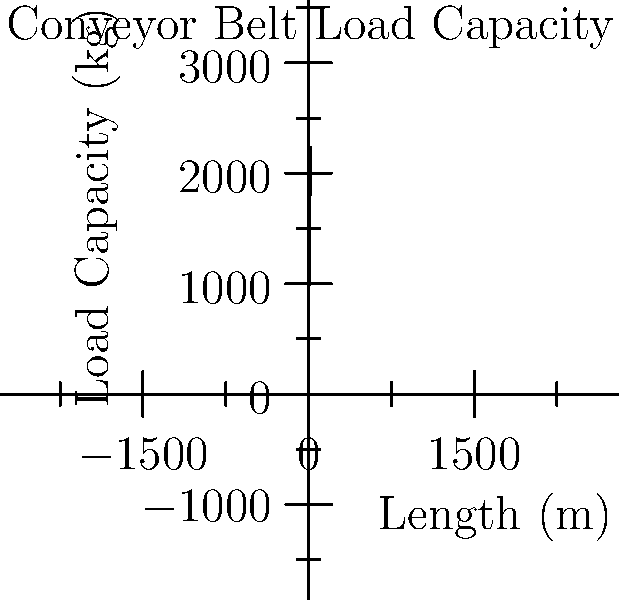As the safety regulations enforcer, you're consulting with a veteran worker about the maximum load capacity of a new conveyor belt. The belt's length is 16 meters, and its motor power is 5 kW. Using the graph, which shows the relationship between belt length and load capacity for a 5 kW motor, what is the maximum load capacity (in kg) for this conveyor belt? To determine the maximum load capacity of the conveyor belt, we'll follow these steps:

1. Identify the given information:
   - Belt length: 16 meters
   - Motor power: 5 kW

2. Examine the graph:
   - The x-axis represents the belt length in meters
   - The y-axis represents the load capacity in kg
   - The curve shows the relationship between length and capacity for a 5 kW motor

3. Locate the point on the graph:
   - Find 16 meters on the x-axis
   - Move vertically up to the curve

4. Read the corresponding y-value:
   - The y-value at x = 16 is approximately 2000 kg

5. Interpret the result:
   - The maximum load capacity for a 16-meter conveyor belt with a 5 kW motor is about 2000 kg

The graph shows that the relationship between length and load capacity follows the function:

$$ \text{Load Capacity} = 500 \sqrt{\text{Length}} $$

We can verify this mathematically:

$$ \text{Load Capacity} = 500 \sqrt{16} = 500 \times 4 = 2000 \text{ kg} $$

This confirms our graphical estimation.
Answer: 2000 kg 